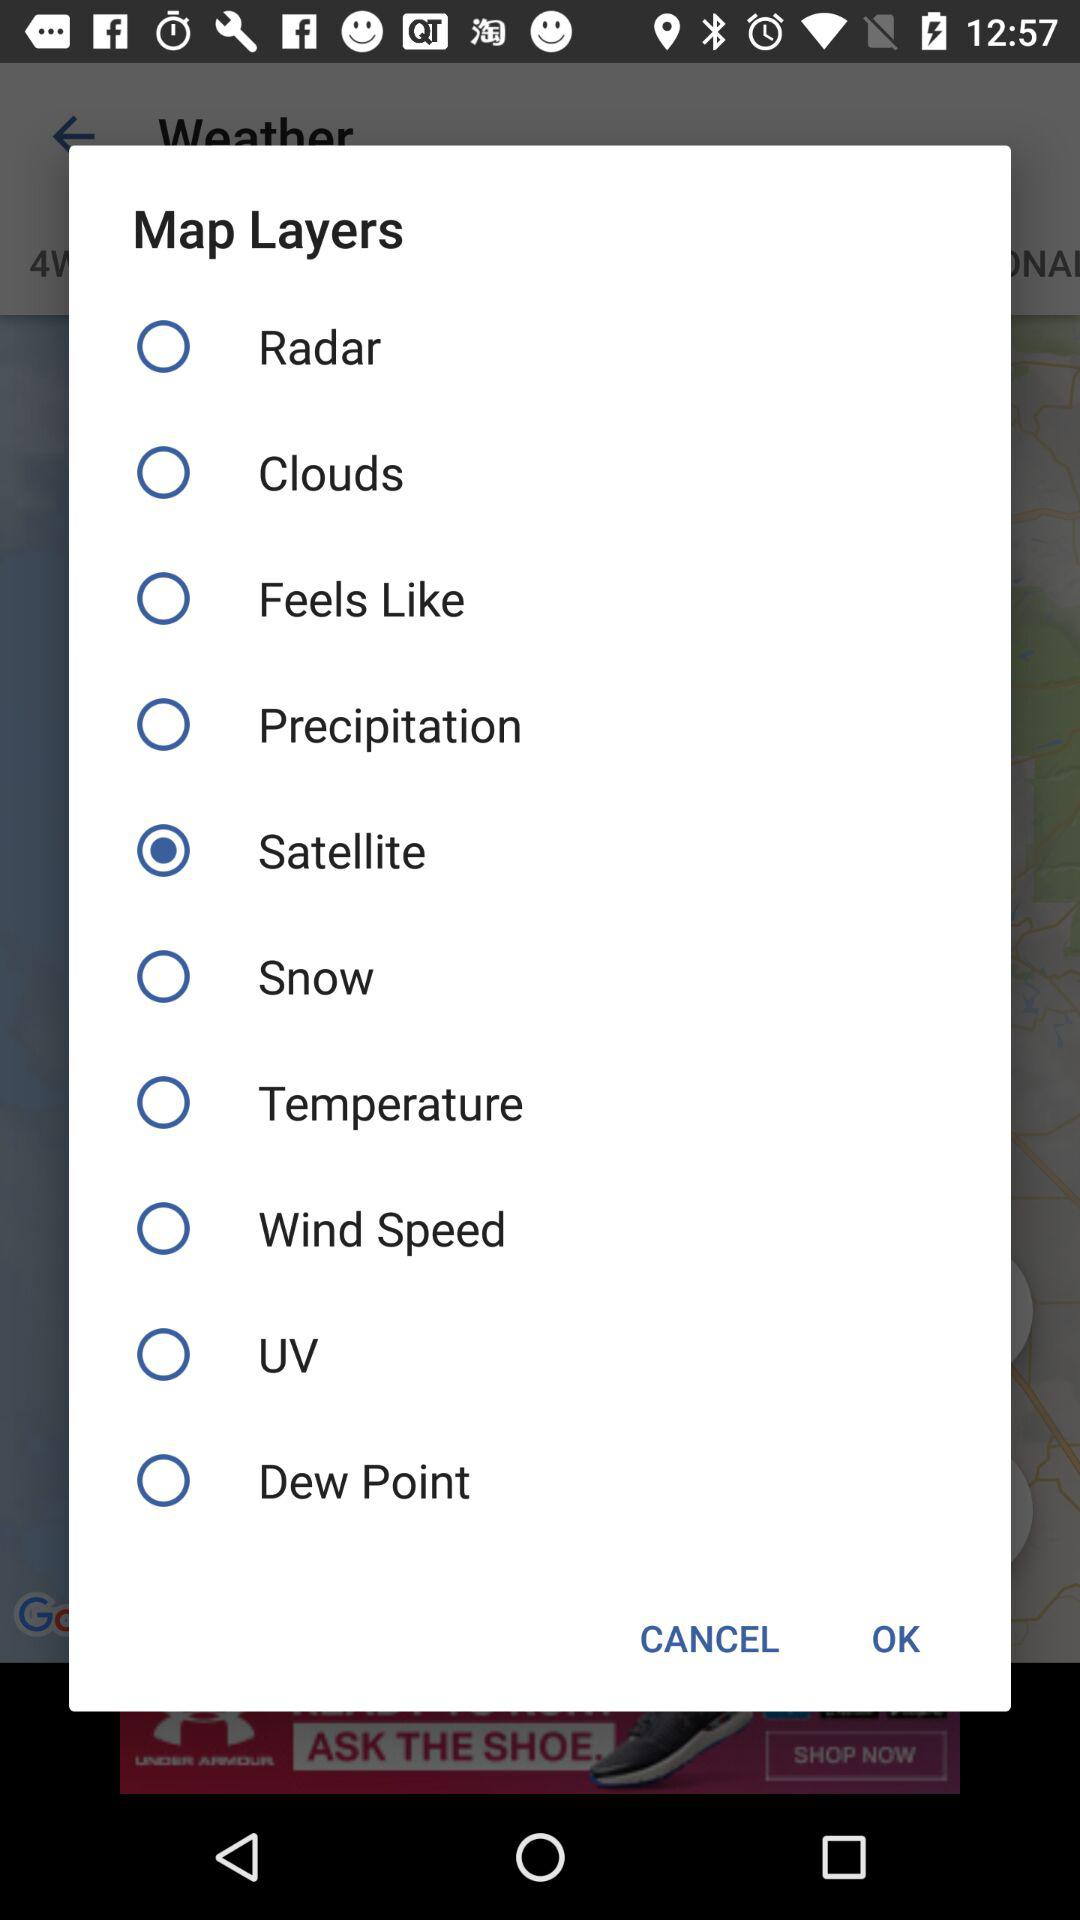Is "UV" selected or not? It is not selected. 